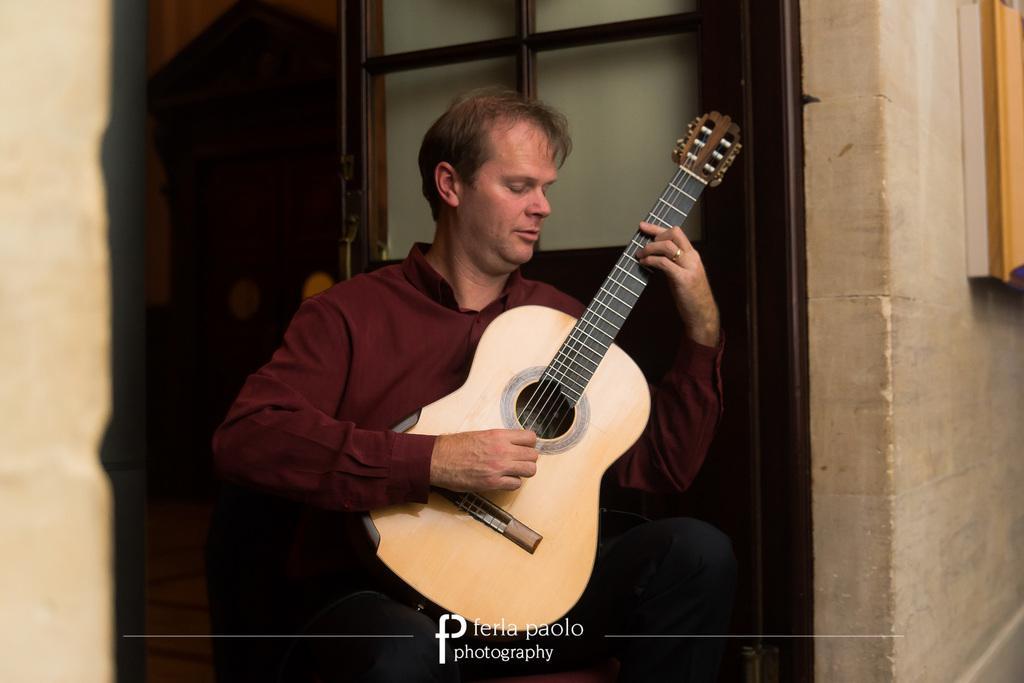Please provide a concise description of this image. In the middle of the image a man is standing and playing guitar behind him there is a door and wall. 